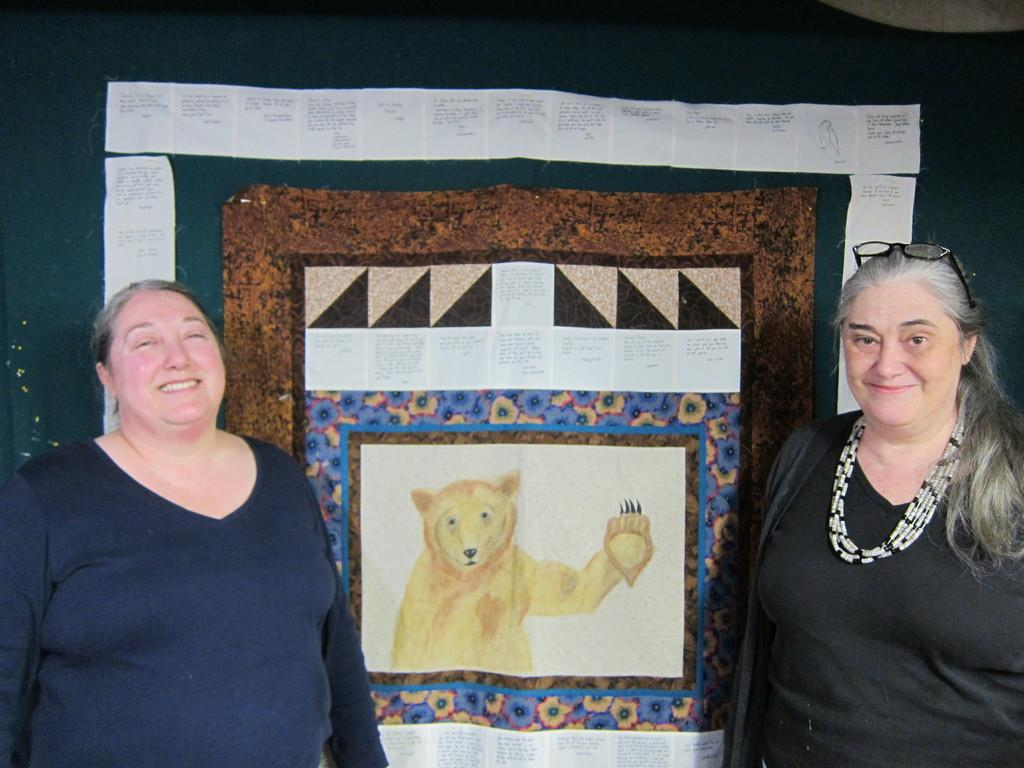How many people are in the image? There are people in the image, but the exact number is not specified. Can you describe any specific features of one of the people? One person is wearing glasses. What can be seen on the board in the background? There are papers with text on a board in the background. What type of drawing is visible in the background? There is a sketch of an animal in the background. How does the friction between the people affect the control of the situation in the image? There is no mention of friction or control in the image, so it is not possible to answer this question. 